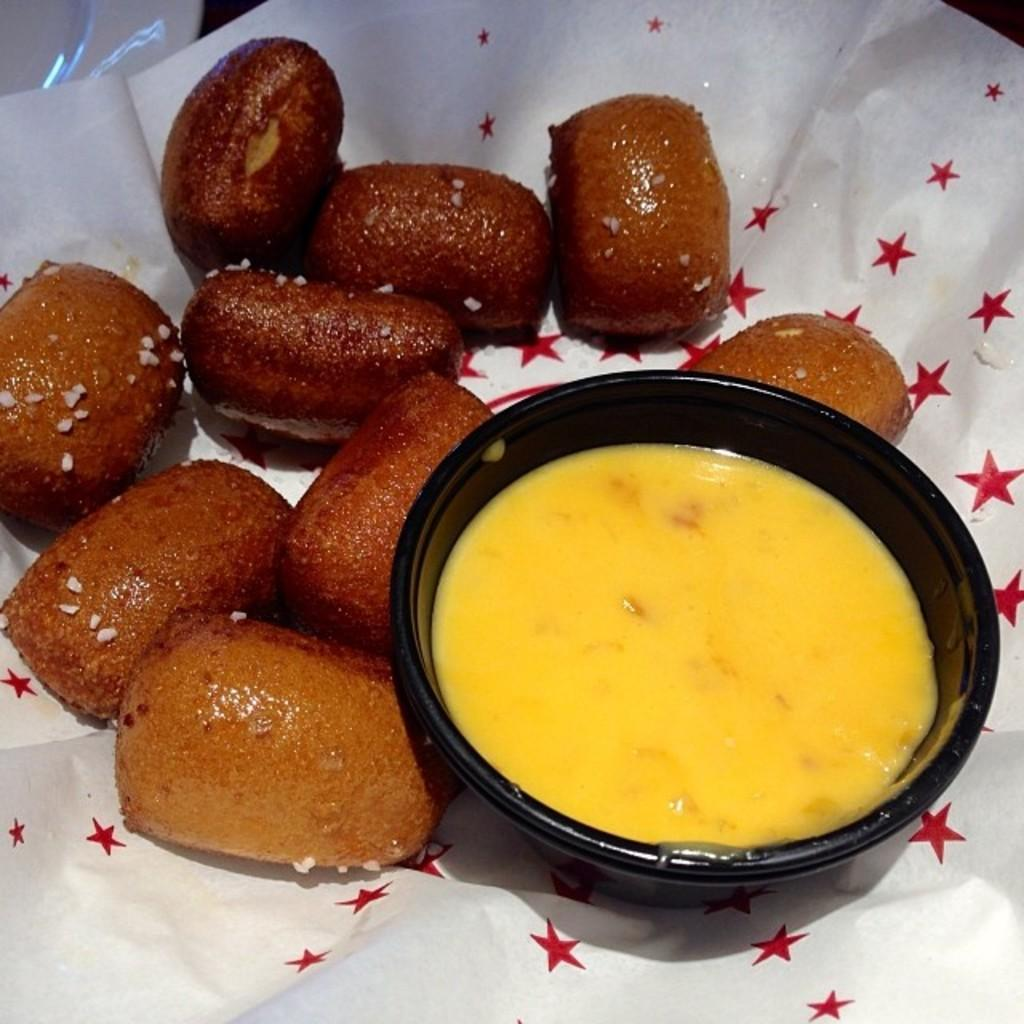What type of items can be seen in the image? The image contains food. Can you see a skateboarding worm in the image? No, there is no skateboarding worm present in the image. 